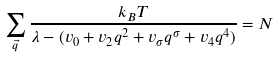Convert formula to latex. <formula><loc_0><loc_0><loc_500><loc_500>\sum _ { \vec { q } } \frac { k _ { B } T } { \lambda - ( v _ { 0 } + v _ { 2 } q ^ { 2 } + v _ { \sigma } q ^ { \sigma } + v _ { 4 } q ^ { 4 } ) } = N</formula> 